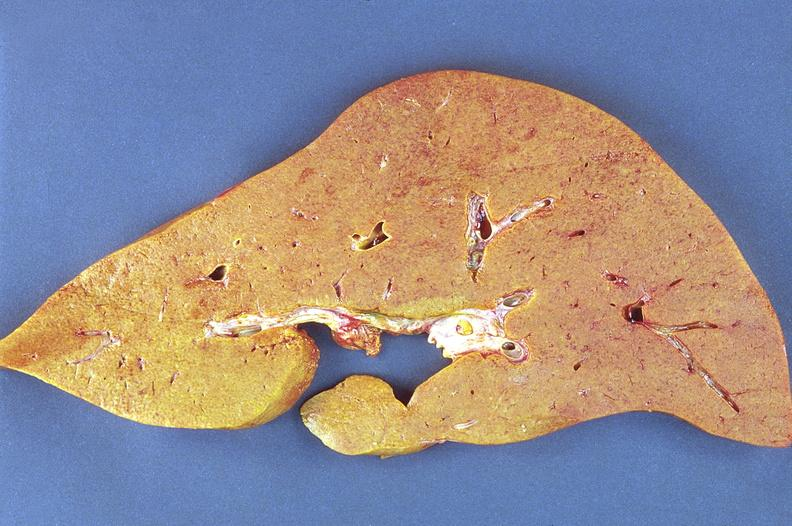what is present?
Answer the question using a single word or phrase. Hepatobiliary 